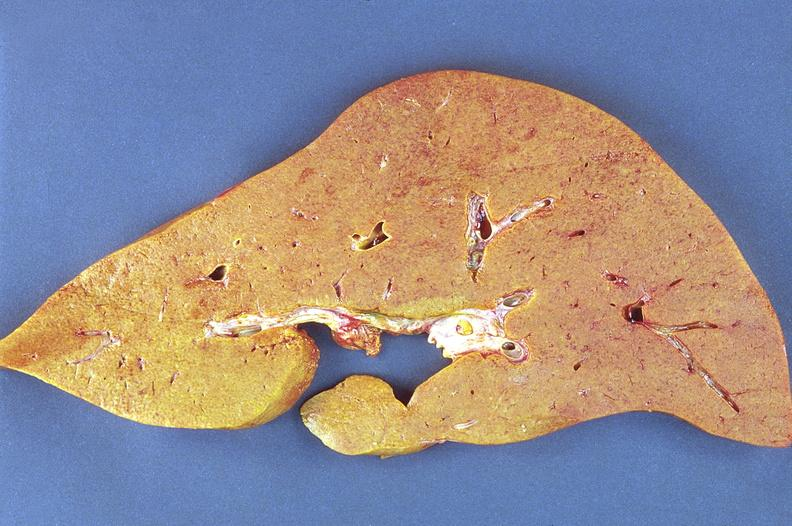what is present?
Answer the question using a single word or phrase. Hepatobiliary 